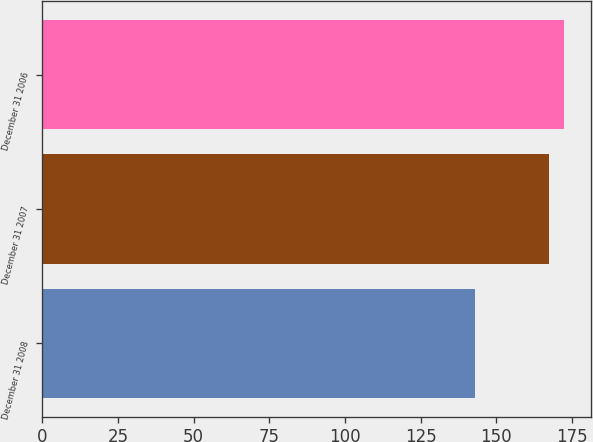<chart> <loc_0><loc_0><loc_500><loc_500><bar_chart><fcel>December 31 2008<fcel>December 31 2007<fcel>December 31 2006<nl><fcel>143<fcel>167.3<fcel>172.5<nl></chart> 